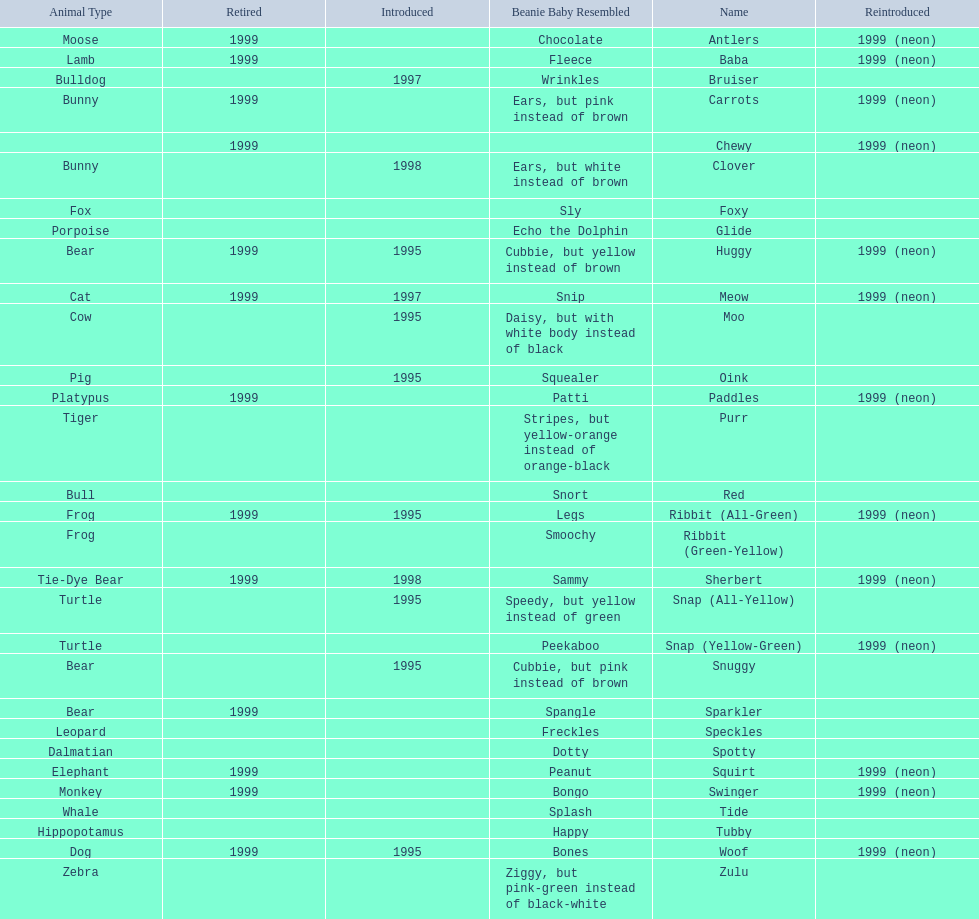What are all the pillow pals? Antlers, Baba, Bruiser, Carrots, Chewy, Clover, Foxy, Glide, Huggy, Meow, Moo, Oink, Paddles, Purr, Red, Ribbit (All-Green), Ribbit (Green-Yellow), Sherbert, Snap (All-Yellow), Snap (Yellow-Green), Snuggy, Sparkler, Speckles, Spotty, Squirt, Swinger, Tide, Tubby, Woof, Zulu. Which is the only without a listed animal type? Chewy. 